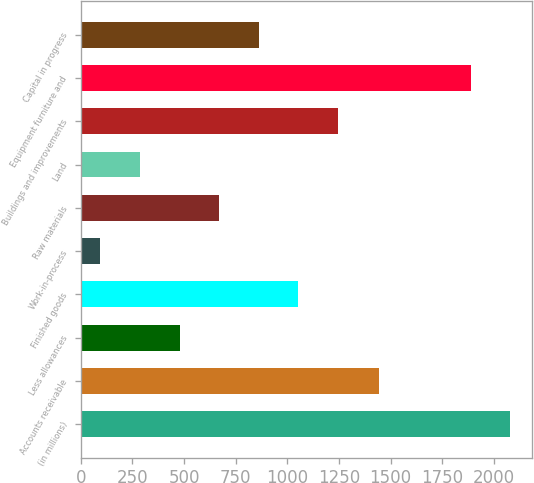Convert chart to OTSL. <chart><loc_0><loc_0><loc_500><loc_500><bar_chart><fcel>(in millions)<fcel>Accounts receivable<fcel>Less allowances<fcel>Finished goods<fcel>Work-in-process<fcel>Raw materials<fcel>Land<fcel>Buildings and improvements<fcel>Equipment furniture and<fcel>Capital in progress<nl><fcel>2080.5<fcel>1445<fcel>478<fcel>1052.5<fcel>95<fcel>669.5<fcel>286.5<fcel>1244<fcel>1889<fcel>861<nl></chart> 